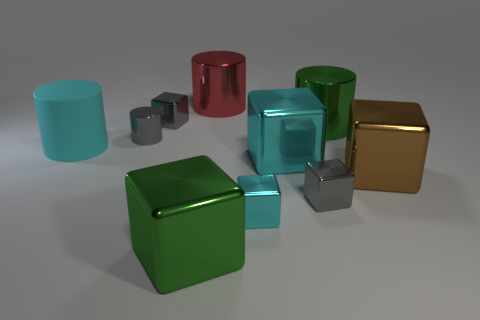Is there anything else that has the same color as the large rubber object?
Your answer should be compact. Yes. The cube that is behind the green metallic thing that is behind the big brown shiny thing is what color?
Provide a succinct answer. Gray. Is there a tiny yellow object?
Give a very brief answer. No. What is the color of the cube that is left of the large red thing and behind the tiny cyan block?
Ensure brevity in your answer.  Gray. Does the gray metal thing in front of the small cylinder have the same size as the green thing that is behind the big cyan cube?
Your answer should be compact. No. What number of other things are the same size as the brown shiny cube?
Give a very brief answer. 5. How many cyan shiny objects are to the left of the tiny gray cylinder that is behind the small cyan metal object?
Make the answer very short. 0. Are there fewer large cubes behind the green metal cylinder than blocks?
Offer a very short reply. Yes. What is the shape of the cyan object left of the big metal cube that is in front of the tiny gray metallic thing that is right of the small cyan block?
Ensure brevity in your answer.  Cylinder. Is the red object the same shape as the large brown object?
Your response must be concise. No. 